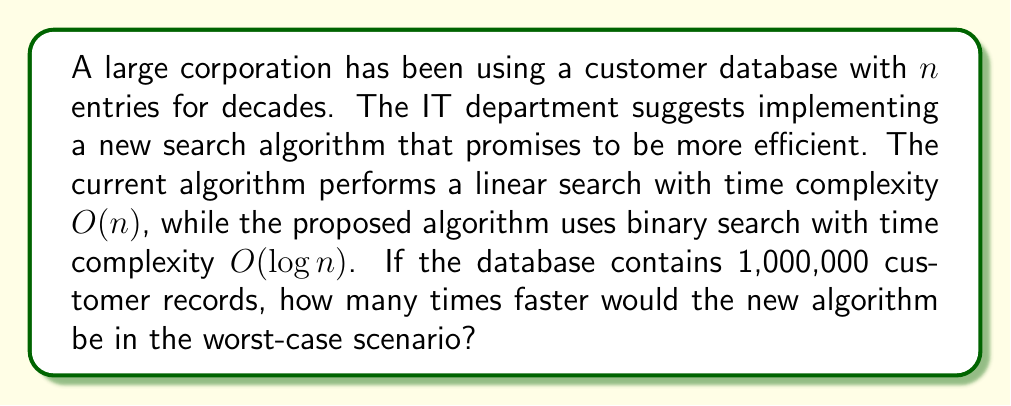Can you solve this math problem? To solve this problem, we need to compare the time complexities of the two algorithms:

1. Current algorithm (linear search): $O(n)$
2. Proposed algorithm (binary search): $O(\log n)$

Let's break down the solution step-by-step:

1. Given: $n = 1,000,000$ (number of customer records)

2. For linear search:
   - Worst-case time complexity: $T_{\text{linear}} = O(n) = n$
   - In this case: $T_{\text{linear}} = 1,000,000$

3. For binary search:
   - Worst-case time complexity: $T_{\text{binary}} = O(\log n) = \log_2 n$
   - In this case: $T_{\text{binary}} = \log_2(1,000,000)$

4. Calculate $\log_2(1,000,000)$:
   $$\log_2(1,000,000) \approx 19.93 \approx 20$$

5. Calculate the speed-up factor:
   $$\text{Speed-up} = \frac{T_{\text{linear}}}{T_{\text{binary}}} = \frac{1,000,000}{20} = 50,000$$

Therefore, in the worst-case scenario, the new binary search algorithm would be approximately 50,000 times faster than the current linear search algorithm for a database of 1,000,000 customer records.
Answer: The new binary search algorithm would be approximately 50,000 times faster than the current linear search algorithm in the worst-case scenario. 